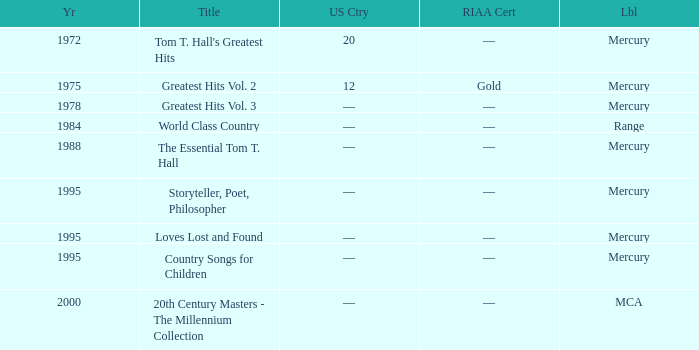What is the title of the album that had a RIAA of gold? Greatest Hits Vol. 2. 